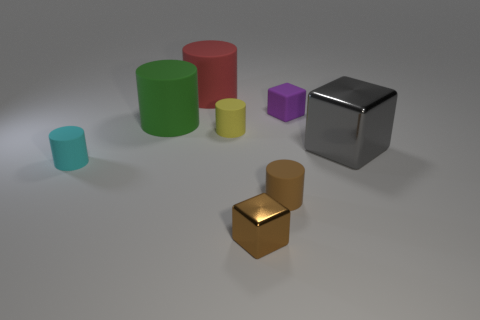Subtract 2 cylinders. How many cylinders are left? 3 Subtract all small cubes. How many cubes are left? 1 Subtract all brown cylinders. How many cylinders are left? 4 Subtract all gray cylinders. Subtract all brown blocks. How many cylinders are left? 5 Add 2 red cylinders. How many objects exist? 10 Subtract all cubes. How many objects are left? 5 Subtract all purple cylinders. Subtract all tiny metal objects. How many objects are left? 7 Add 3 tiny yellow objects. How many tiny yellow objects are left? 4 Add 7 tiny yellow balls. How many tiny yellow balls exist? 7 Subtract 0 blue balls. How many objects are left? 8 